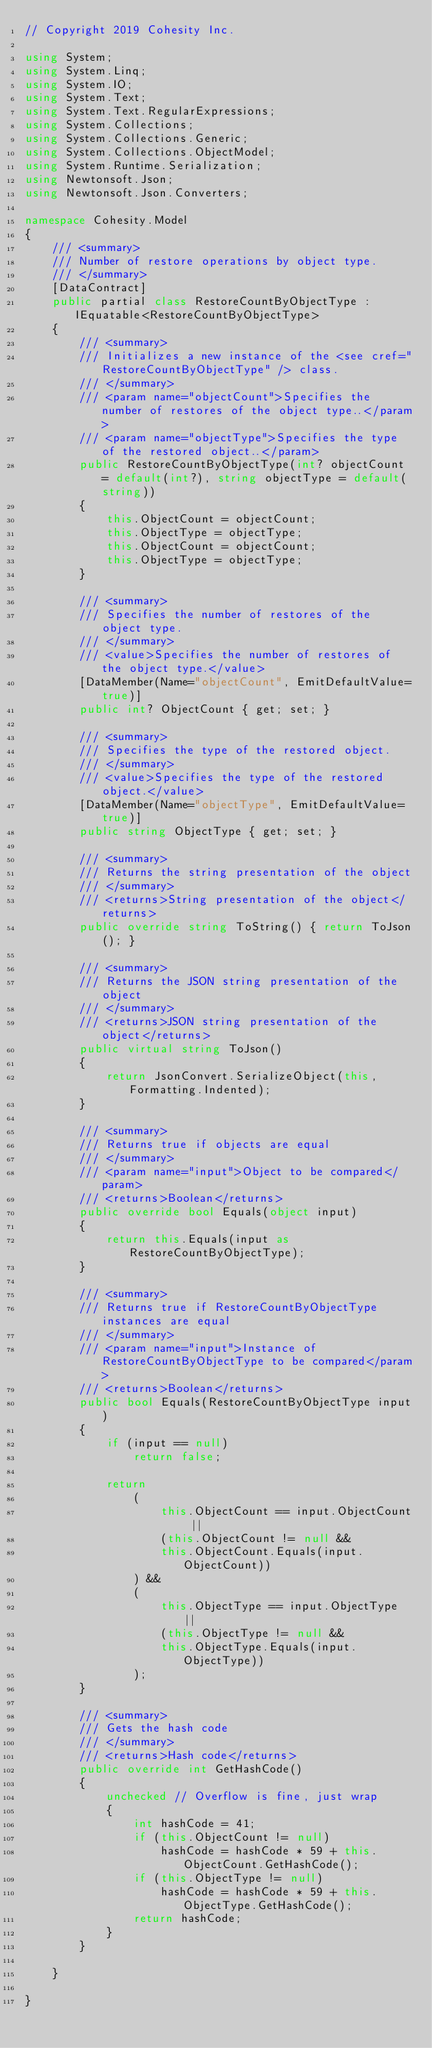<code> <loc_0><loc_0><loc_500><loc_500><_C#_>// Copyright 2019 Cohesity Inc.

using System;
using System.Linq;
using System.IO;
using System.Text;
using System.Text.RegularExpressions;
using System.Collections;
using System.Collections.Generic;
using System.Collections.ObjectModel;
using System.Runtime.Serialization;
using Newtonsoft.Json;
using Newtonsoft.Json.Converters;

namespace Cohesity.Model
{
    /// <summary>
    /// Number of restore operations by object type.
    /// </summary>
    [DataContract]
    public partial class RestoreCountByObjectType :  IEquatable<RestoreCountByObjectType>
    {
        /// <summary>
        /// Initializes a new instance of the <see cref="RestoreCountByObjectType" /> class.
        /// </summary>
        /// <param name="objectCount">Specifies the number of restores of the object type..</param>
        /// <param name="objectType">Specifies the type of the restored object..</param>
        public RestoreCountByObjectType(int? objectCount = default(int?), string objectType = default(string))
        {
            this.ObjectCount = objectCount;
            this.ObjectType = objectType;
            this.ObjectCount = objectCount;
            this.ObjectType = objectType;
        }
        
        /// <summary>
        /// Specifies the number of restores of the object type.
        /// </summary>
        /// <value>Specifies the number of restores of the object type.</value>
        [DataMember(Name="objectCount", EmitDefaultValue=true)]
        public int? ObjectCount { get; set; }

        /// <summary>
        /// Specifies the type of the restored object.
        /// </summary>
        /// <value>Specifies the type of the restored object.</value>
        [DataMember(Name="objectType", EmitDefaultValue=true)]
        public string ObjectType { get; set; }

        /// <summary>
        /// Returns the string presentation of the object
        /// </summary>
        /// <returns>String presentation of the object</returns>
        public override string ToString() { return ToJson(); }
  
        /// <summary>
        /// Returns the JSON string presentation of the object
        /// </summary>
        /// <returns>JSON string presentation of the object</returns>
        public virtual string ToJson()
        {
            return JsonConvert.SerializeObject(this, Formatting.Indented);
        }

        /// <summary>
        /// Returns true if objects are equal
        /// </summary>
        /// <param name="input">Object to be compared</param>
        /// <returns>Boolean</returns>
        public override bool Equals(object input)
        {
            return this.Equals(input as RestoreCountByObjectType);
        }

        /// <summary>
        /// Returns true if RestoreCountByObjectType instances are equal
        /// </summary>
        /// <param name="input">Instance of RestoreCountByObjectType to be compared</param>
        /// <returns>Boolean</returns>
        public bool Equals(RestoreCountByObjectType input)
        {
            if (input == null)
                return false;

            return 
                (
                    this.ObjectCount == input.ObjectCount ||
                    (this.ObjectCount != null &&
                    this.ObjectCount.Equals(input.ObjectCount))
                ) && 
                (
                    this.ObjectType == input.ObjectType ||
                    (this.ObjectType != null &&
                    this.ObjectType.Equals(input.ObjectType))
                );
        }

        /// <summary>
        /// Gets the hash code
        /// </summary>
        /// <returns>Hash code</returns>
        public override int GetHashCode()
        {
            unchecked // Overflow is fine, just wrap
            {
                int hashCode = 41;
                if (this.ObjectCount != null)
                    hashCode = hashCode * 59 + this.ObjectCount.GetHashCode();
                if (this.ObjectType != null)
                    hashCode = hashCode * 59 + this.ObjectType.GetHashCode();
                return hashCode;
            }
        }

    }

}

</code> 